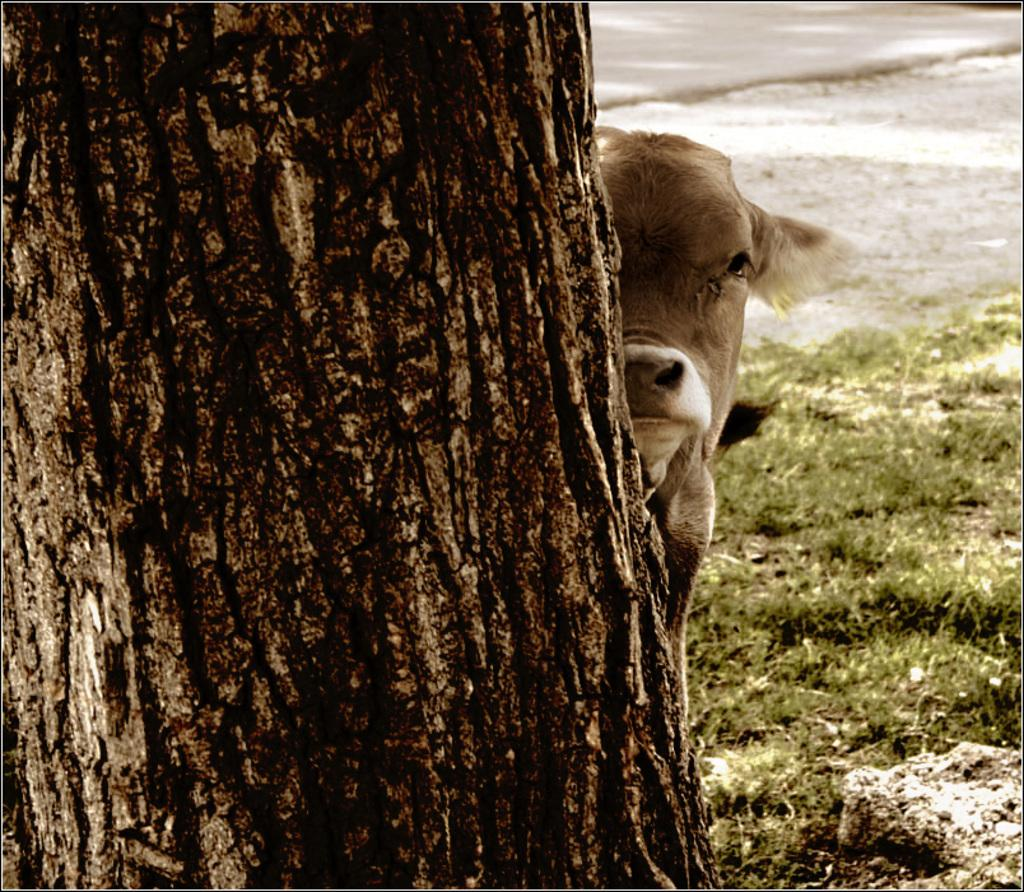What part of a tree can be seen in the image? The bark of a tree is visible in the image. What type of living creature is present in the image? There is an animal in the image. What type of vegetation is present in the image? Grass is present in the image. What can be seen in the background of the image? There is a road and a path in the background of the image. What type of fowl is sitting on the title in the image? There is no fowl or title present in the image. What type of turkey can be seen in the image? There is no turkey present in the image. 